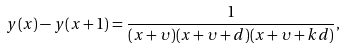<formula> <loc_0><loc_0><loc_500><loc_500>y ( x ) - y ( x + 1 ) = \frac { 1 } { ( x + \upsilon ) ( x + \upsilon + d ) ( x + \upsilon + k d ) } ,</formula> 